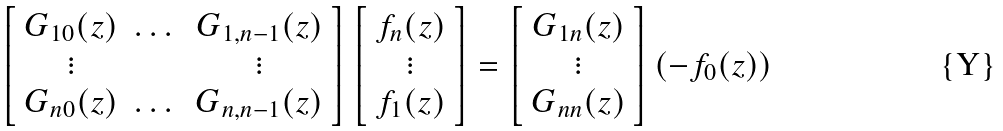<formula> <loc_0><loc_0><loc_500><loc_500>\left [ \begin{array} { c c c } G _ { 1 0 } ( z ) & \dots & G _ { 1 , n - 1 } ( z ) \\ \vdots & \, & \vdots \\ G _ { n 0 } ( z ) & \dots & G _ { n , n - 1 } ( z ) \\ \end{array} \right ] \left [ \begin{array} { c } f _ { n } ( z ) \\ \vdots \\ f _ { 1 } ( z ) \\ \end{array} \right ] = \left [ \begin{array} { c } G _ { 1 n } ( z ) \\ \vdots \\ G _ { n n } ( z ) \\ \end{array} \right ] ( - f _ { 0 } ( z ) )</formula> 